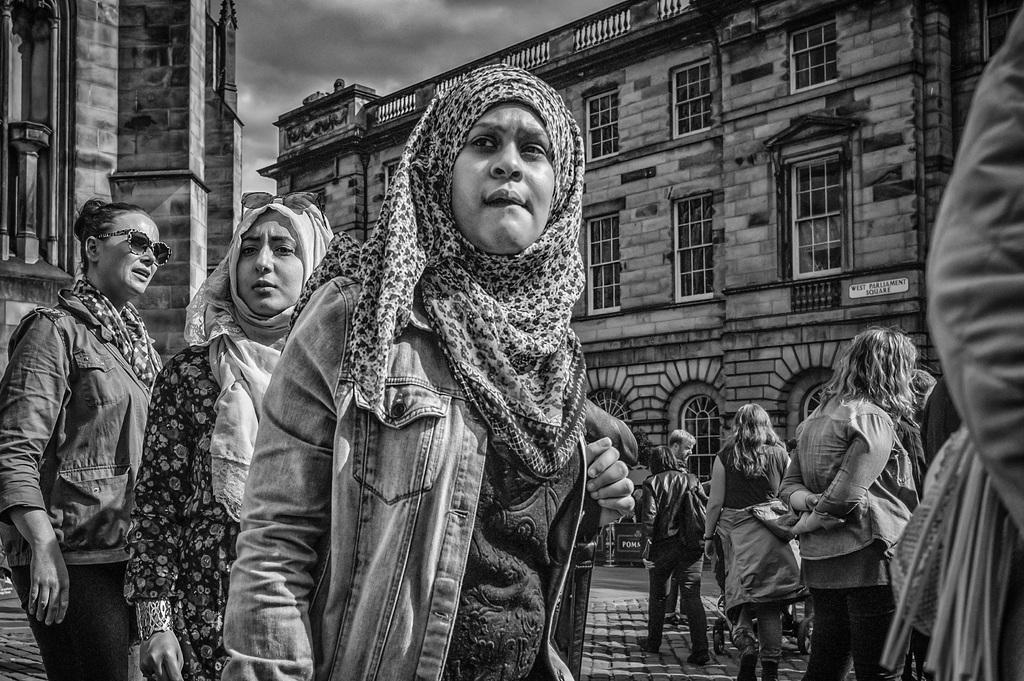How would you summarize this image in a sentence or two? In this image we can see many people. There are few buildings and they are having many windows. There is a board on the wall of the building at the right side of the image. We can see the cloudy sky in the image. 